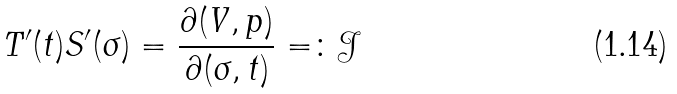<formula> <loc_0><loc_0><loc_500><loc_500>T ^ { \prime } ( t ) S ^ { \prime } ( \sigma ) = \frac { \partial ( V , p ) } { \partial ( \sigma , t ) } = \colon \mathcal { J }</formula> 